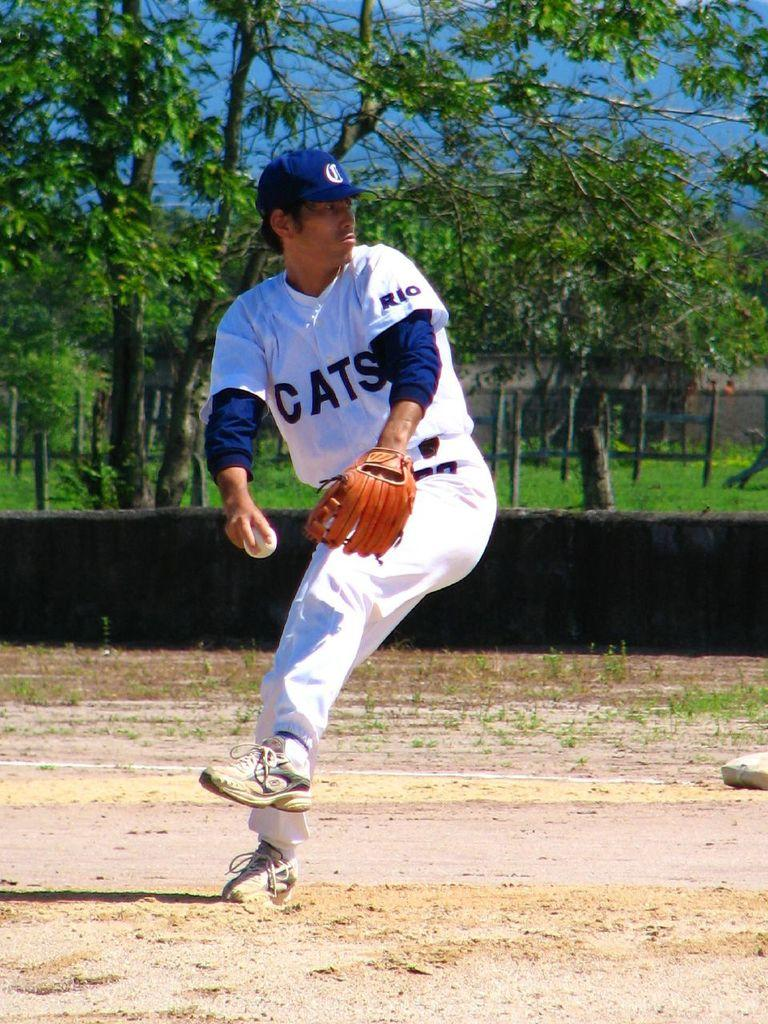<image>
Give a short and clear explanation of the subsequent image. A baseball player is wearing a jersey with CATS on the front. 